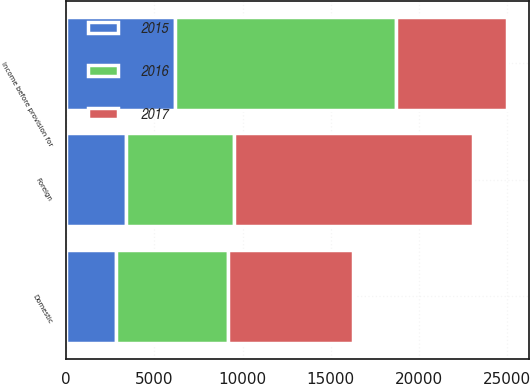Convert chart to OTSL. <chart><loc_0><loc_0><loc_500><loc_500><stacked_bar_chart><ecel><fcel>Domestic<fcel>Foreign<fcel>Income before provision for<nl><fcel>2017<fcel>7079<fcel>13515<fcel>6281<nl><fcel>2016<fcel>6368<fcel>6150<fcel>12518<nl><fcel>2015<fcel>2802<fcel>3392<fcel>6194<nl></chart> 